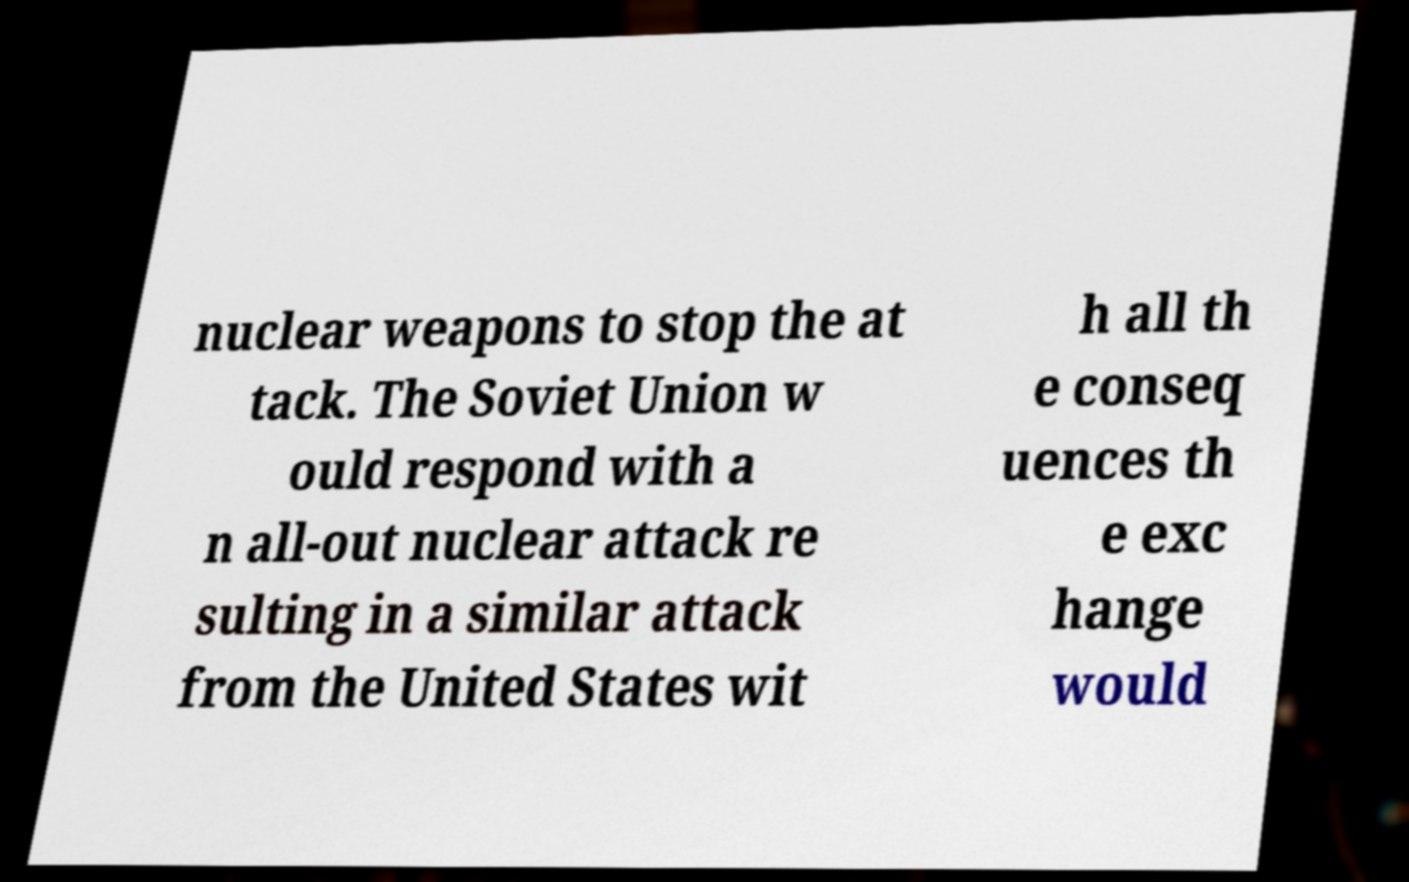Can you accurately transcribe the text from the provided image for me? nuclear weapons to stop the at tack. The Soviet Union w ould respond with a n all-out nuclear attack re sulting in a similar attack from the United States wit h all th e conseq uences th e exc hange would 